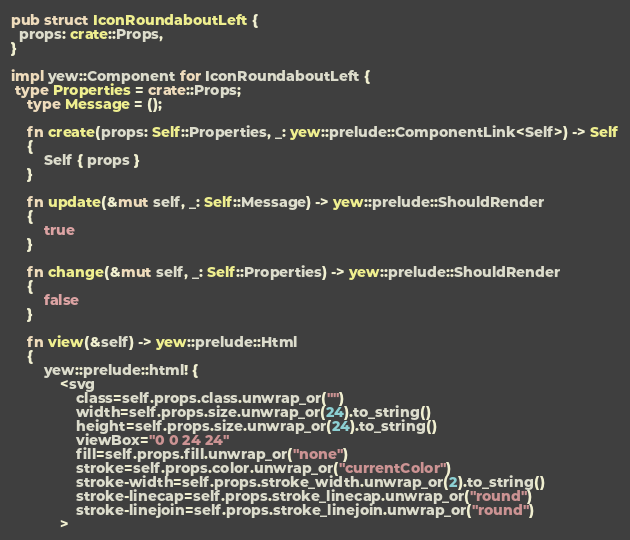Convert code to text. <code><loc_0><loc_0><loc_500><loc_500><_Rust_>
pub struct IconRoundaboutLeft {
  props: crate::Props,
}

impl yew::Component for IconRoundaboutLeft {
 type Properties = crate::Props;
    type Message = ();

    fn create(props: Self::Properties, _: yew::prelude::ComponentLink<Self>) -> Self
    {
        Self { props }
    }

    fn update(&mut self, _: Self::Message) -> yew::prelude::ShouldRender
    {
        true
    }

    fn change(&mut self, _: Self::Properties) -> yew::prelude::ShouldRender
    {
        false
    }

    fn view(&self) -> yew::prelude::Html
    {
        yew::prelude::html! {
            <svg
                class=self.props.class.unwrap_or("")
                width=self.props.size.unwrap_or(24).to_string()
                height=self.props.size.unwrap_or(24).to_string()
                viewBox="0 0 24 24"
                fill=self.props.fill.unwrap_or("none")
                stroke=self.props.color.unwrap_or("currentColor")
                stroke-width=self.props.stroke_width.unwrap_or(2).to_string()
                stroke-linecap=self.props.stroke_linecap.unwrap_or("round")
                stroke-linejoin=self.props.stroke_linejoin.unwrap_or("round")
            ></code> 